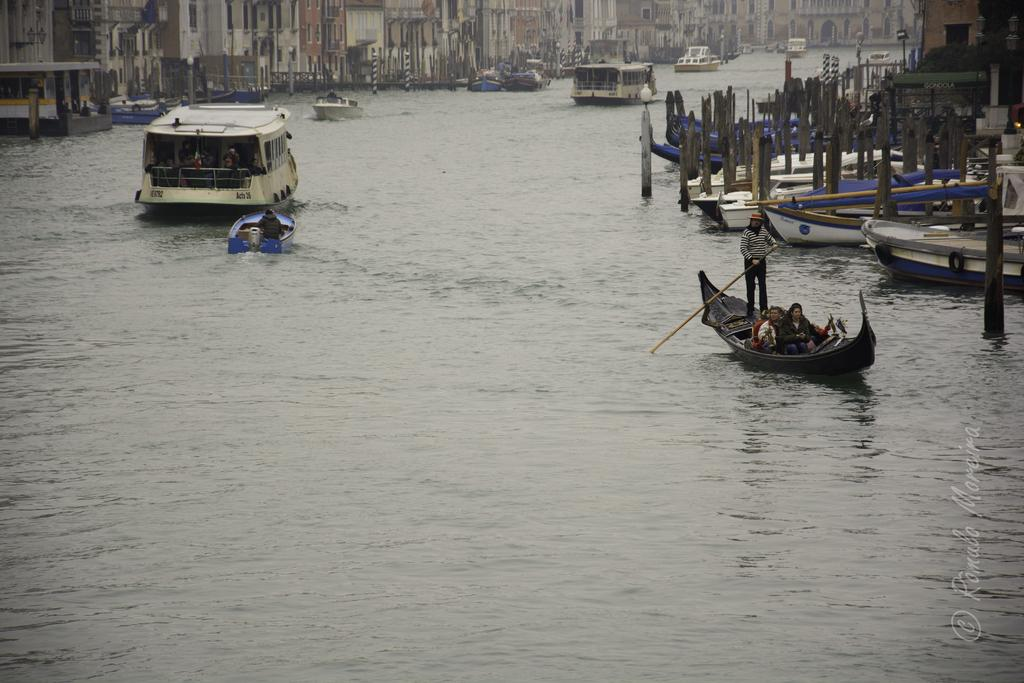What is depicted in the image? There are boats in the image. What are the boats doing in the image? The boats are sailing on a river. What can be seen in the background of the image? There are buildings in the background of the image. What type of boot is being used by the boaters in the image? There is no boot present in the image, as the focus is on the boats sailing on the river and the buildings in the background. 